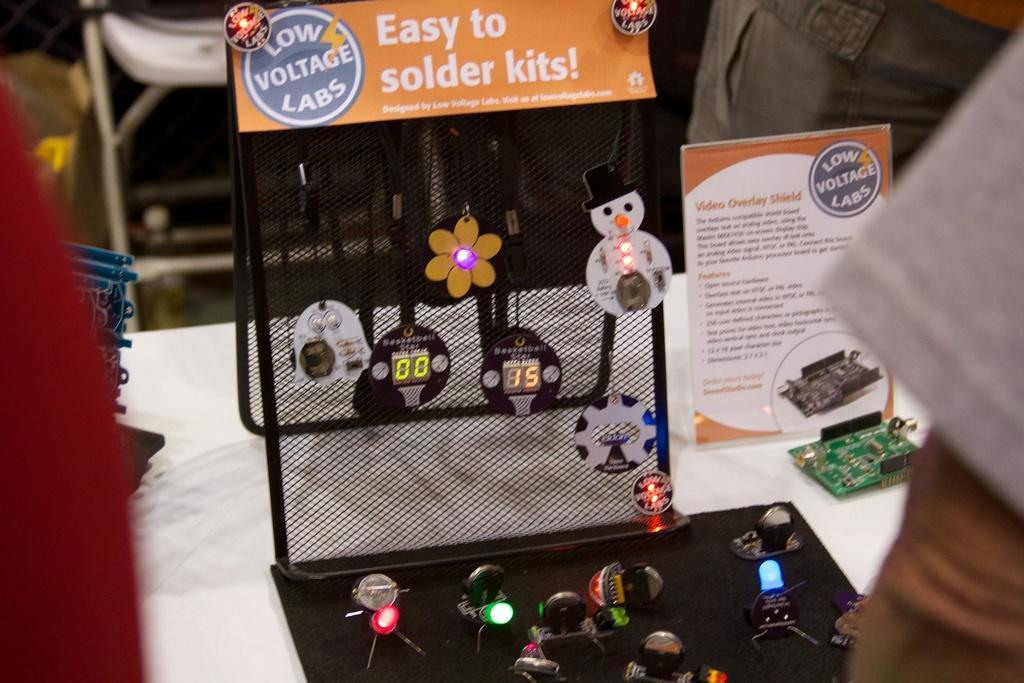How would you summarize this image in a sentence or two? In this image, we can see some gadgets on the table. There is a chair in the top left of the image. 